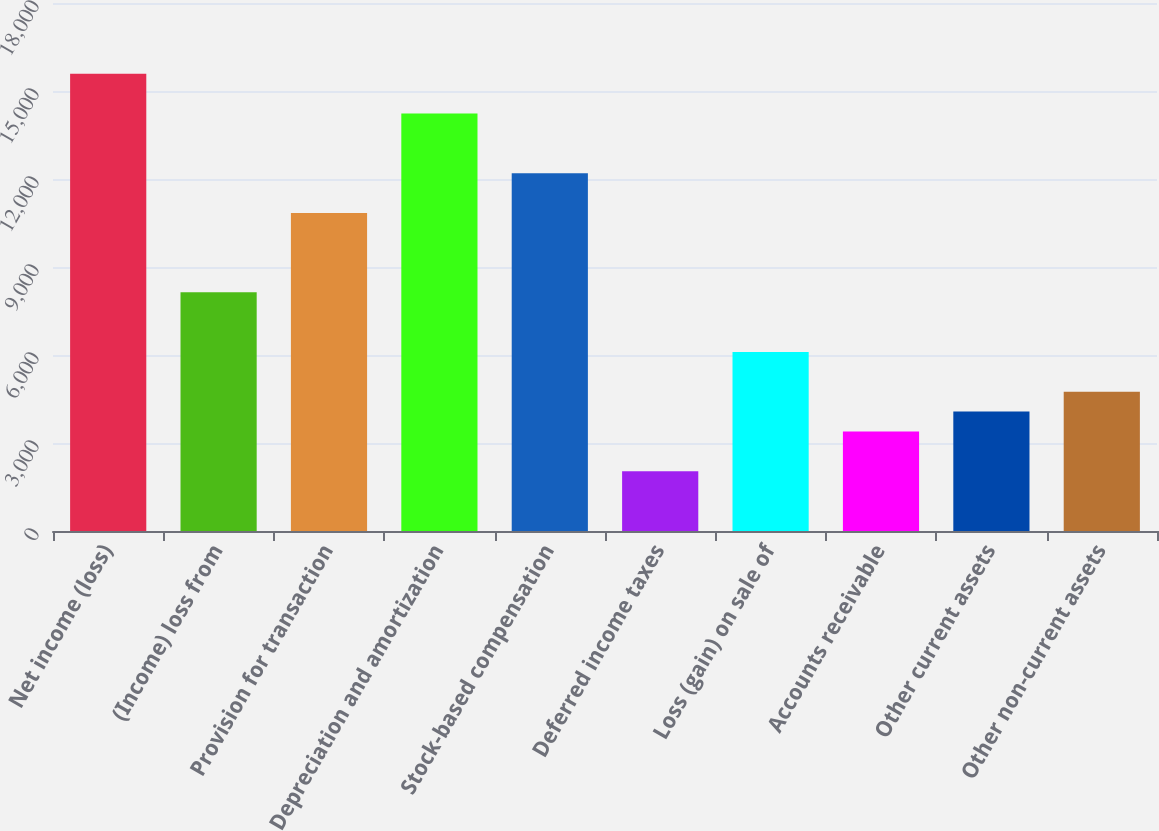<chart> <loc_0><loc_0><loc_500><loc_500><bar_chart><fcel>Net income (loss)<fcel>(Income) loss from<fcel>Provision for transaction<fcel>Depreciation and amortization<fcel>Stock-based compensation<fcel>Deferred income taxes<fcel>Loss (gain) on sale of<fcel>Accounts receivable<fcel>Other current assets<fcel>Other non-current assets<nl><fcel>15584.6<fcel>8135.4<fcel>10844.2<fcel>14230.2<fcel>12198.6<fcel>2040.6<fcel>6103.8<fcel>3395<fcel>4072.2<fcel>4749.4<nl></chart> 